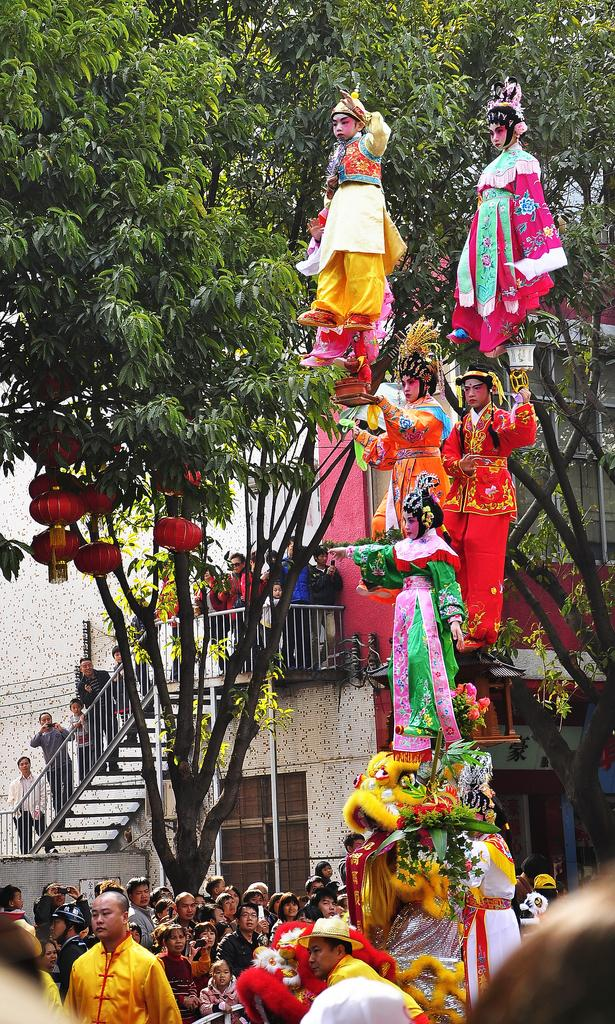How many people are in the image? There is a group of people in the image. What is the position of the people in the image? The people are standing on the ground. What architectural feature can be seen in the image? There are steps in the image. What can be seen in the background of the image? There are trees and a building in the background of the image. What type of string is being used to hold up the legs of the people in the image? There is no string or legs mentioned in the image; the people are standing on the ground. 